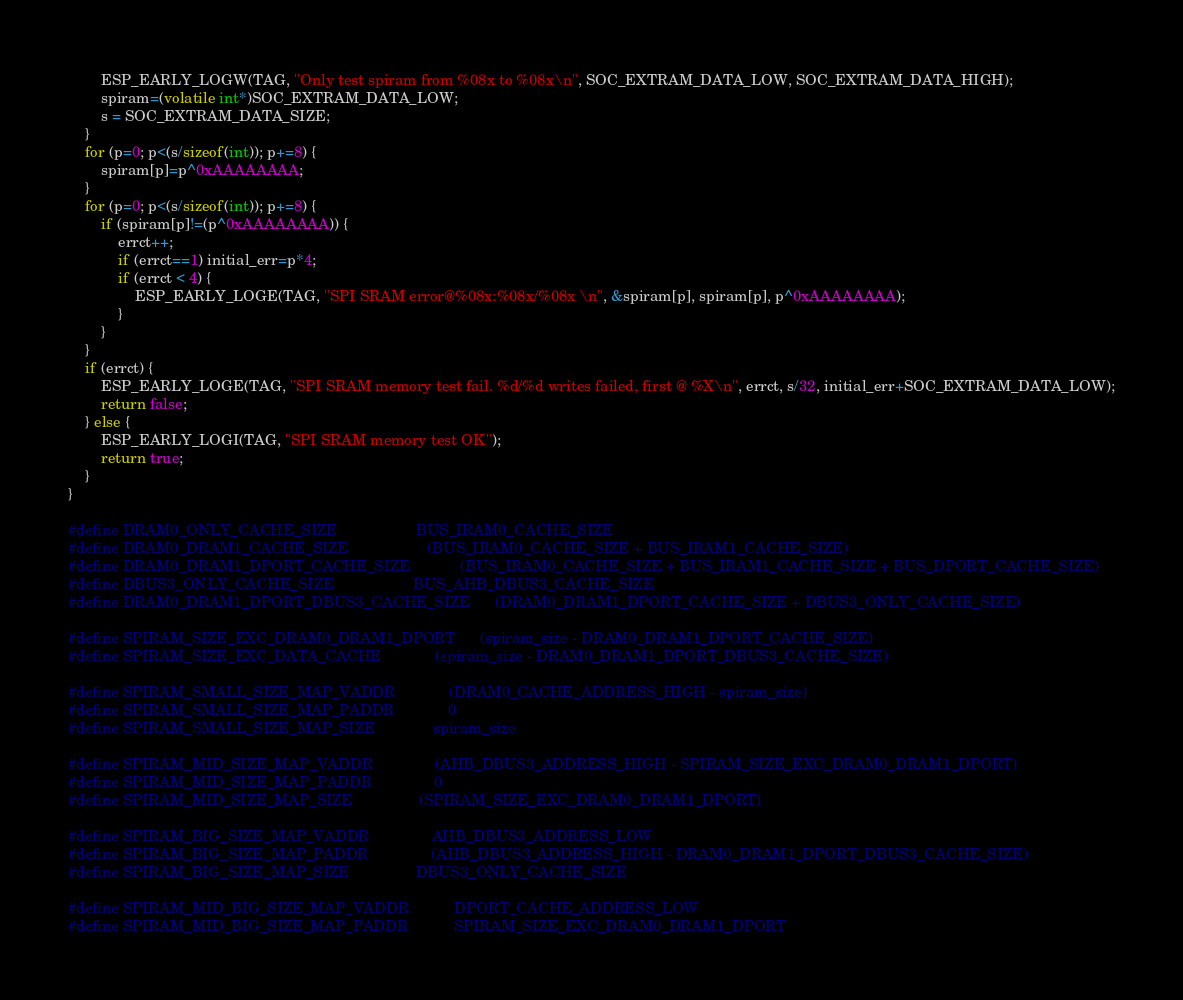Convert code to text. <code><loc_0><loc_0><loc_500><loc_500><_C_>        ESP_EARLY_LOGW(TAG, "Only test spiram from %08x to %08x\n", SOC_EXTRAM_DATA_LOW, SOC_EXTRAM_DATA_HIGH);
        spiram=(volatile int*)SOC_EXTRAM_DATA_LOW;
        s = SOC_EXTRAM_DATA_SIZE;
    }
    for (p=0; p<(s/sizeof(int)); p+=8) {
        spiram[p]=p^0xAAAAAAAA;
    }
    for (p=0; p<(s/sizeof(int)); p+=8) {
        if (spiram[p]!=(p^0xAAAAAAAA)) {
            errct++;
            if (errct==1) initial_err=p*4;
            if (errct < 4) {
                ESP_EARLY_LOGE(TAG, "SPI SRAM error@%08x:%08x/%08x \n", &spiram[p], spiram[p], p^0xAAAAAAAA);
            }
        }
    }
    if (errct) {
        ESP_EARLY_LOGE(TAG, "SPI SRAM memory test fail. %d/%d writes failed, first @ %X\n", errct, s/32, initial_err+SOC_EXTRAM_DATA_LOW);
        return false;
    } else {
        ESP_EARLY_LOGI(TAG, "SPI SRAM memory test OK");
        return true;
    }
}

#define DRAM0_ONLY_CACHE_SIZE                   BUS_IRAM0_CACHE_SIZE
#define DRAM0_DRAM1_CACHE_SIZE	                (BUS_IRAM0_CACHE_SIZE + BUS_IRAM1_CACHE_SIZE)
#define DRAM0_DRAM1_DPORT_CACHE_SIZE            (BUS_IRAM0_CACHE_SIZE + BUS_IRAM1_CACHE_SIZE + BUS_DPORT_CACHE_SIZE)
#define DBUS3_ONLY_CACHE_SIZE                   BUS_AHB_DBUS3_CACHE_SIZE
#define DRAM0_DRAM1_DPORT_DBUS3_CACHE_SIZE      (DRAM0_DRAM1_DPORT_CACHE_SIZE + DBUS3_ONLY_CACHE_SIZE)

#define SPIRAM_SIZE_EXC_DRAM0_DRAM1_DPORT      (spiram_size - DRAM0_DRAM1_DPORT_CACHE_SIZE)
#define SPIRAM_SIZE_EXC_DATA_CACHE             (spiram_size - DRAM0_DRAM1_DPORT_DBUS3_CACHE_SIZE)

#define SPIRAM_SMALL_SIZE_MAP_VADDR             (DRAM0_CACHE_ADDRESS_HIGH - spiram_size)
#define SPIRAM_SMALL_SIZE_MAP_PADDR             0
#define SPIRAM_SMALL_SIZE_MAP_SIZE              spiram_size

#define SPIRAM_MID_SIZE_MAP_VADDR               (AHB_DBUS3_ADDRESS_HIGH - SPIRAM_SIZE_EXC_DRAM0_DRAM1_DPORT)
#define SPIRAM_MID_SIZE_MAP_PADDR               0
#define SPIRAM_MID_SIZE_MAP_SIZE                (SPIRAM_SIZE_EXC_DRAM0_DRAM1_DPORT)

#define SPIRAM_BIG_SIZE_MAP_VADDR               AHB_DBUS3_ADDRESS_LOW
#define SPIRAM_BIG_SIZE_MAP_PADDR               (AHB_DBUS3_ADDRESS_HIGH - DRAM0_DRAM1_DPORT_DBUS3_CACHE_SIZE)
#define SPIRAM_BIG_SIZE_MAP_SIZE                DBUS3_ONLY_CACHE_SIZE

#define SPIRAM_MID_BIG_SIZE_MAP_VADDR           DPORT_CACHE_ADDRESS_LOW
#define SPIRAM_MID_BIG_SIZE_MAP_PADDR           SPIRAM_SIZE_EXC_DRAM0_DRAM1_DPORT</code> 